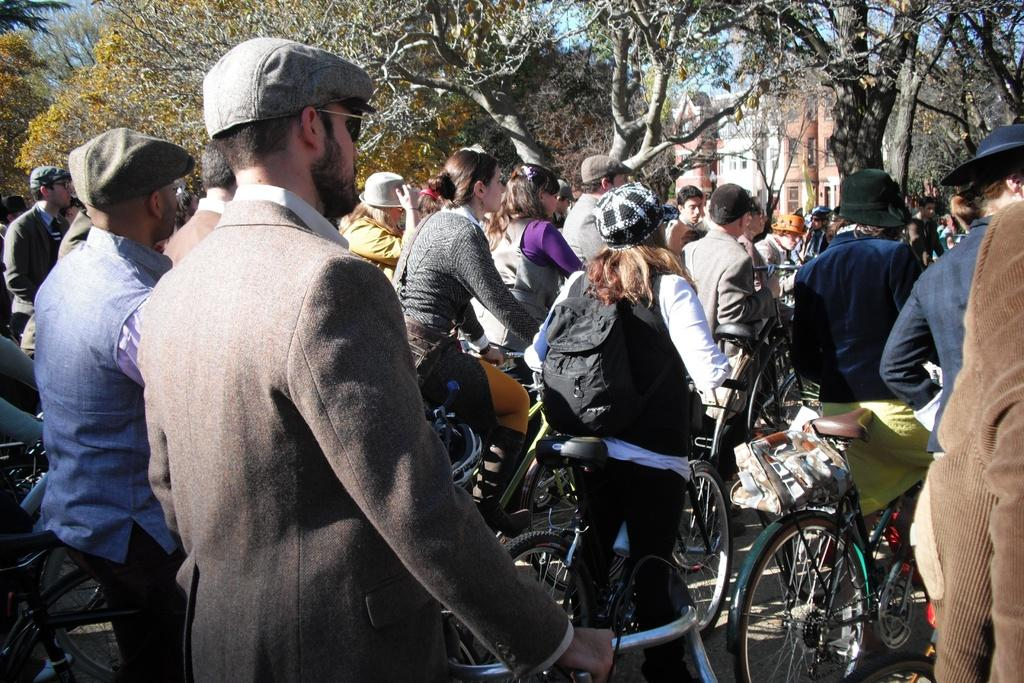What are the persons in the image doing? The persons in the image are riding cycles. What can be seen in the background of the image? There are trees, the sky, and a building visible in the background. What type of partner is the grandmother holding in the image? There is no grandmother or partner present in the image; it features a group of persons riding cycles. 